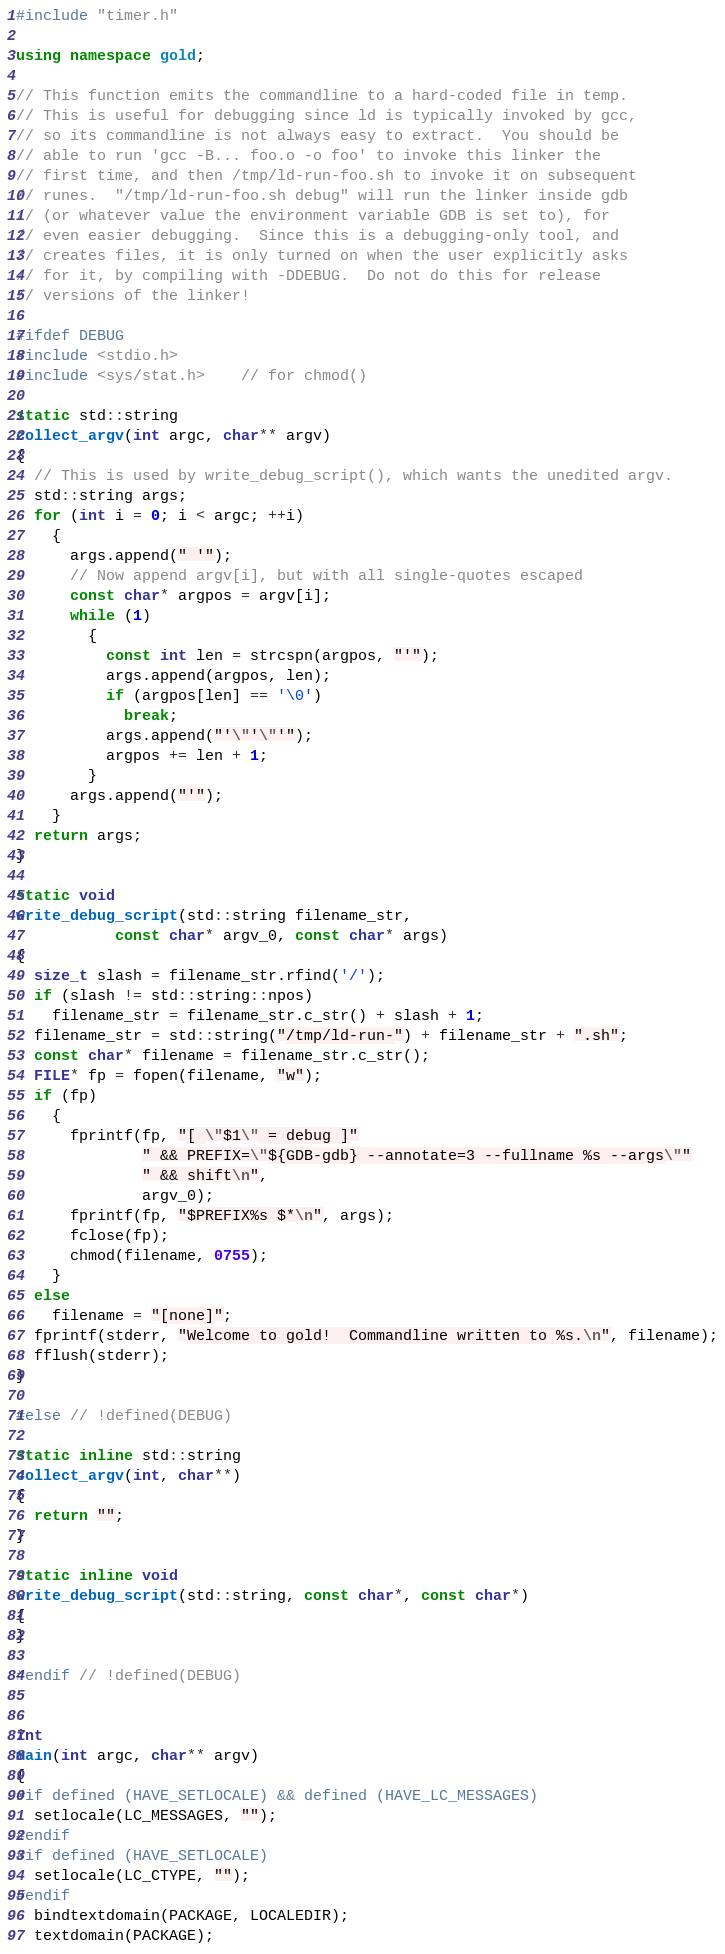<code> <loc_0><loc_0><loc_500><loc_500><_C++_>#include "timer.h"

using namespace gold;

// This function emits the commandline to a hard-coded file in temp.
// This is useful for debugging since ld is typically invoked by gcc,
// so its commandline is not always easy to extract.  You should be
// able to run 'gcc -B... foo.o -o foo' to invoke this linker the
// first time, and then /tmp/ld-run-foo.sh to invoke it on subsequent
// runes.  "/tmp/ld-run-foo.sh debug" will run the linker inside gdb
// (or whatever value the environment variable GDB is set to), for
// even easier debugging.  Since this is a debugging-only tool, and
// creates files, it is only turned on when the user explicitly asks
// for it, by compiling with -DDEBUG.  Do not do this for release
// versions of the linker!

#ifdef DEBUG
#include <stdio.h>
#include <sys/stat.h>    // for chmod()

static std::string
collect_argv(int argc, char** argv)
{
  // This is used by write_debug_script(), which wants the unedited argv.
  std::string args;
  for (int i = 0; i < argc; ++i)
    {
      args.append(" '");
      // Now append argv[i], but with all single-quotes escaped
      const char* argpos = argv[i];
      while (1)
        {
          const int len = strcspn(argpos, "'");
          args.append(argpos, len);
          if (argpos[len] == '\0')
            break;
          args.append("'\"'\"'");
          argpos += len + 1;
        }
      args.append("'");
    }
  return args;
}

static void
write_debug_script(std::string filename_str,
		   const char* argv_0, const char* args)
{
  size_t slash = filename_str.rfind('/');
  if (slash != std::string::npos)
    filename_str = filename_str.c_str() + slash + 1;
  filename_str = std::string("/tmp/ld-run-") + filename_str + ".sh";
  const char* filename = filename_str.c_str();
  FILE* fp = fopen(filename, "w");
  if (fp)
    {
      fprintf(fp, "[ \"$1\" = debug ]"
              " && PREFIX=\"${GDB-gdb} --annotate=3 --fullname %s --args\""
              " && shift\n",
              argv_0);
      fprintf(fp, "$PREFIX%s $*\n", args);
      fclose(fp);
      chmod(filename, 0755);
    }
  else
    filename = "[none]";
  fprintf(stderr, "Welcome to gold!  Commandline written to %s.\n", filename);
  fflush(stderr);
}

#else // !defined(DEBUG)

static inline std::string
collect_argv(int, char**)
{
  return "";
}

static inline void
write_debug_script(std::string, const char*, const char*)
{
}

#endif // !defined(DEBUG)


int
main(int argc, char** argv)
{
#if defined (HAVE_SETLOCALE) && defined (HAVE_LC_MESSAGES)
  setlocale(LC_MESSAGES, "");
#endif
#if defined (HAVE_SETLOCALE)
  setlocale(LC_CTYPE, "");
#endif
  bindtextdomain(PACKAGE, LOCALEDIR);
  textdomain(PACKAGE);
</code> 